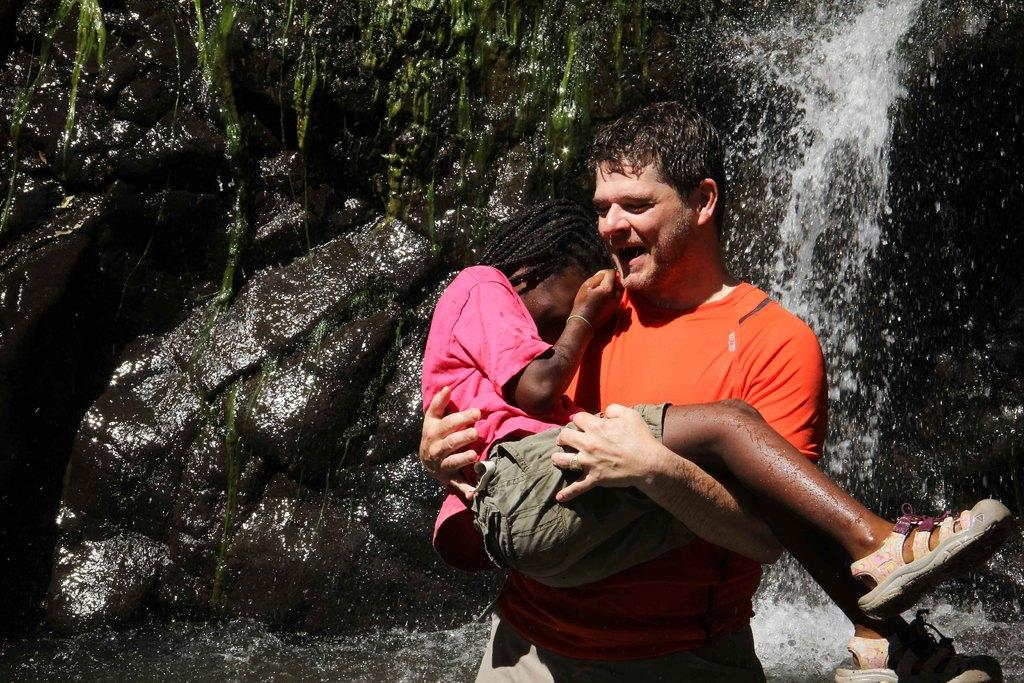Who is present in the image? There is a man in the image. What is the man doing in the image? The man is holding another person in the image. What natural feature can be seen in the image? There is a waterfall in the image. How is the waterfall situated in the image? The waterfall is on rocks in the image. What type of icicle can be seen hanging from the church in the image? There is no church or icicle present in the image. 